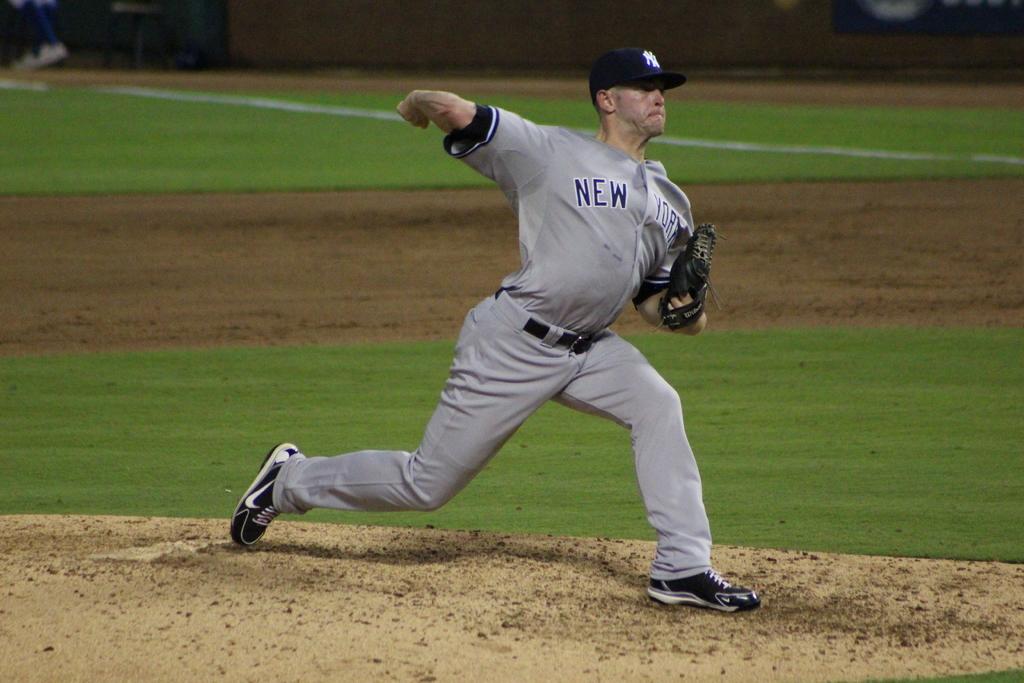What are the initials on his hat?
Give a very brief answer. Ny. 